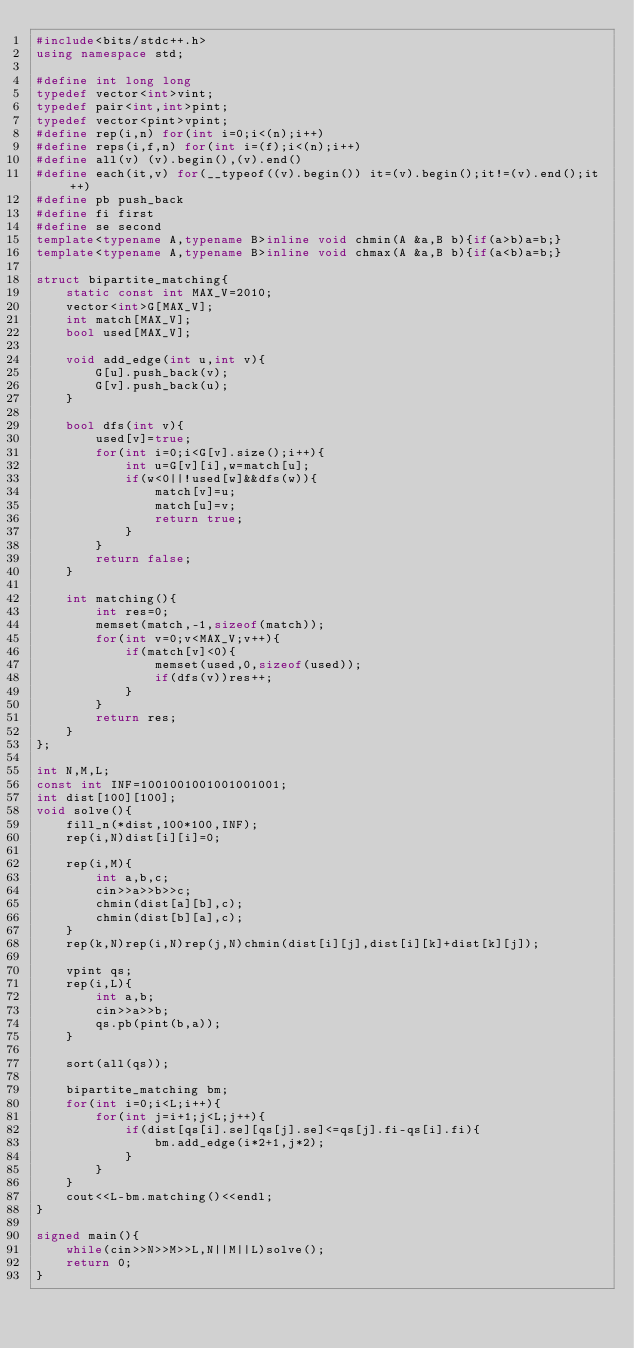<code> <loc_0><loc_0><loc_500><loc_500><_C++_>#include<bits/stdc++.h>
using namespace std;

#define int long long
typedef vector<int>vint;
typedef pair<int,int>pint;
typedef vector<pint>vpint;
#define rep(i,n) for(int i=0;i<(n);i++)
#define reps(i,f,n) for(int i=(f);i<(n);i++)
#define all(v) (v).begin(),(v).end()
#define each(it,v) for(__typeof((v).begin()) it=(v).begin();it!=(v).end();it++)
#define pb push_back
#define fi first
#define se second
template<typename A,typename B>inline void chmin(A &a,B b){if(a>b)a=b;}
template<typename A,typename B>inline void chmax(A &a,B b){if(a<b)a=b;}

struct bipartite_matching{
    static const int MAX_V=2010;
    vector<int>G[MAX_V];
    int match[MAX_V];
    bool used[MAX_V];

    void add_edge(int u,int v){
        G[u].push_back(v);
        G[v].push_back(u);
    }

    bool dfs(int v){
        used[v]=true;
        for(int i=0;i<G[v].size();i++){
            int u=G[v][i],w=match[u];
            if(w<0||!used[w]&&dfs(w)){
                match[v]=u;
                match[u]=v;
                return true;
            }
        }
        return false;
    }

    int matching(){
        int res=0;
        memset(match,-1,sizeof(match));
        for(int v=0;v<MAX_V;v++){
            if(match[v]<0){
                memset(used,0,sizeof(used));
                if(dfs(v))res++;
            }
        }
        return res;
    }
};

int N,M,L;
const int INF=1001001001001001001;
int dist[100][100];
void solve(){
    fill_n(*dist,100*100,INF);
    rep(i,N)dist[i][i]=0;

    rep(i,M){
        int a,b,c;
        cin>>a>>b>>c;
        chmin(dist[a][b],c);
        chmin(dist[b][a],c);
    }
    rep(k,N)rep(i,N)rep(j,N)chmin(dist[i][j],dist[i][k]+dist[k][j]);

    vpint qs;
    rep(i,L){
        int a,b;
        cin>>a>>b;
        qs.pb(pint(b,a));
    }

    sort(all(qs));

    bipartite_matching bm;
    for(int i=0;i<L;i++){
        for(int j=i+1;j<L;j++){
            if(dist[qs[i].se][qs[j].se]<=qs[j].fi-qs[i].fi){
                bm.add_edge(i*2+1,j*2);
            }
        }
    }
    cout<<L-bm.matching()<<endl;
}

signed main(){
    while(cin>>N>>M>>L,N||M||L)solve();
    return 0;
}</code> 